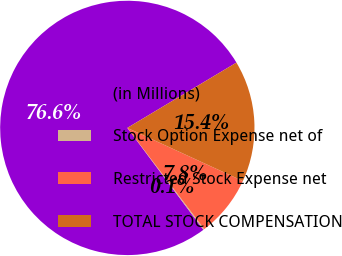Convert chart to OTSL. <chart><loc_0><loc_0><loc_500><loc_500><pie_chart><fcel>(in Millions)<fcel>Stock Option Expense net of<fcel>Restricted Stock Expense net<fcel>TOTAL STOCK COMPENSATION<nl><fcel>76.62%<fcel>0.14%<fcel>7.79%<fcel>15.44%<nl></chart> 